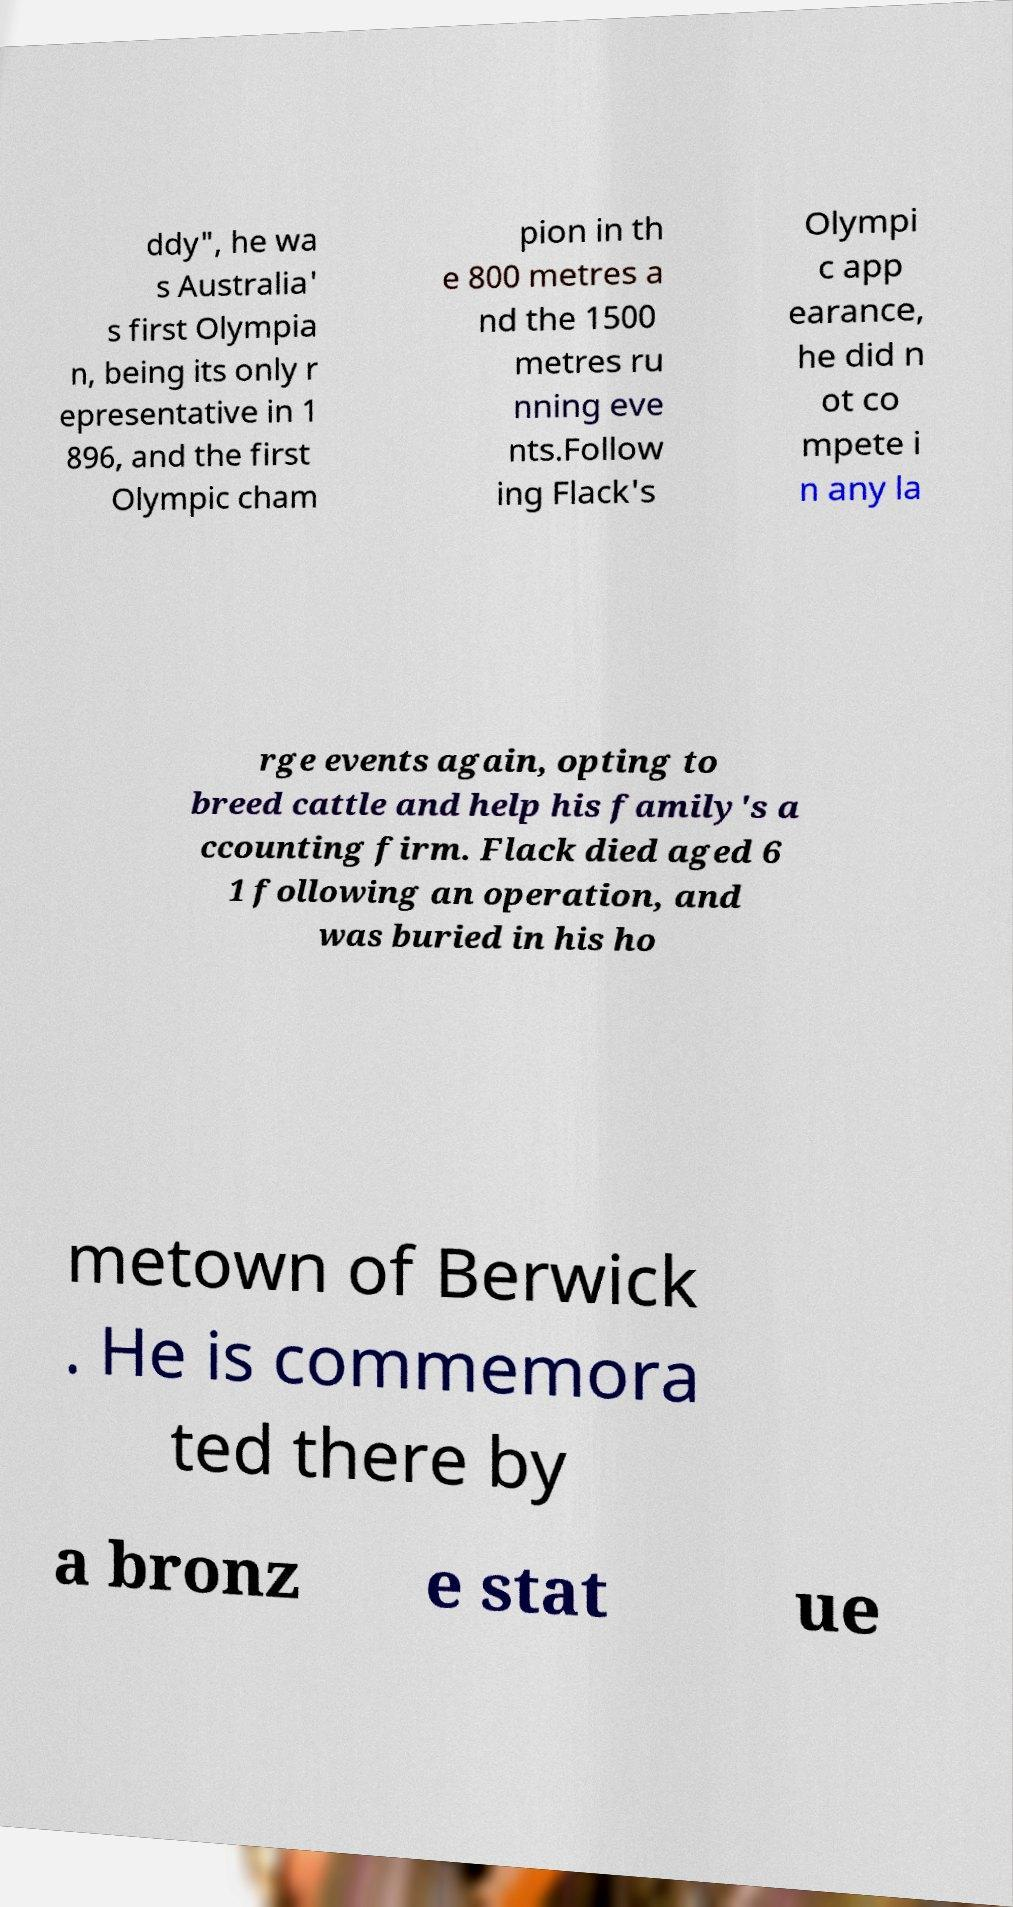Can you accurately transcribe the text from the provided image for me? ddy", he wa s Australia' s first Olympia n, being its only r epresentative in 1 896, and the first Olympic cham pion in th e 800 metres a nd the 1500 metres ru nning eve nts.Follow ing Flack's Olympi c app earance, he did n ot co mpete i n any la rge events again, opting to breed cattle and help his family's a ccounting firm. Flack died aged 6 1 following an operation, and was buried in his ho metown of Berwick . He is commemora ted there by a bronz e stat ue 